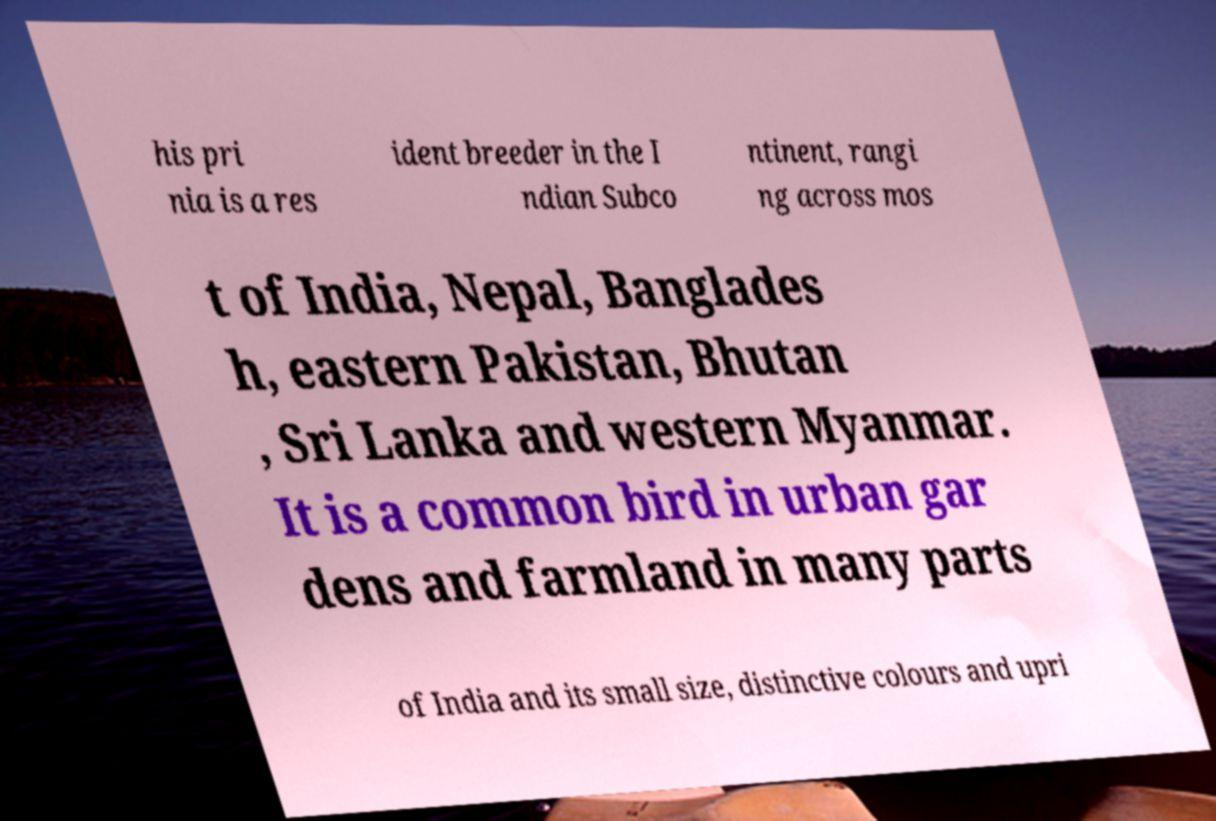Please read and relay the text visible in this image. What does it say? his pri nia is a res ident breeder in the I ndian Subco ntinent, rangi ng across mos t of India, Nepal, Banglades h, eastern Pakistan, Bhutan , Sri Lanka and western Myanmar. It is a common bird in urban gar dens and farmland in many parts of India and its small size, distinctive colours and upri 